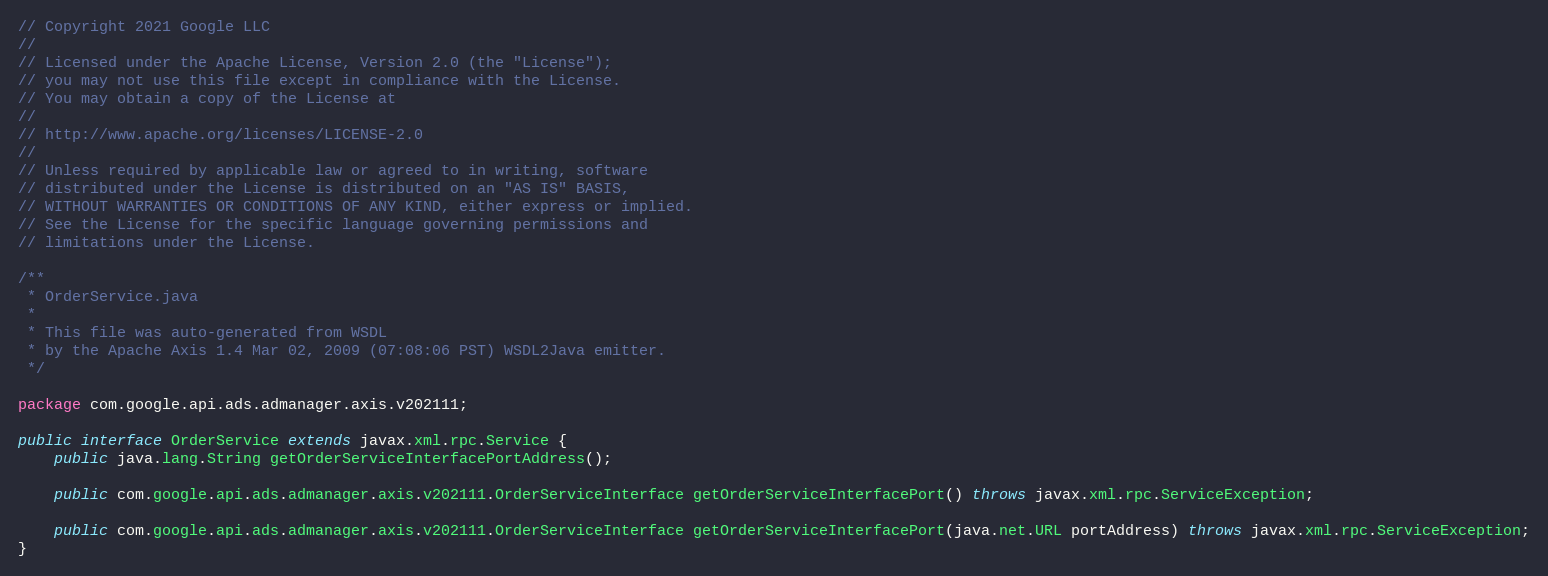<code> <loc_0><loc_0><loc_500><loc_500><_Java_>// Copyright 2021 Google LLC
//
// Licensed under the Apache License, Version 2.0 (the "License");
// you may not use this file except in compliance with the License.
// You may obtain a copy of the License at
//
// http://www.apache.org/licenses/LICENSE-2.0
//
// Unless required by applicable law or agreed to in writing, software
// distributed under the License is distributed on an "AS IS" BASIS,
// WITHOUT WARRANTIES OR CONDITIONS OF ANY KIND, either express or implied.
// See the License for the specific language governing permissions and
// limitations under the License.

/**
 * OrderService.java
 *
 * This file was auto-generated from WSDL
 * by the Apache Axis 1.4 Mar 02, 2009 (07:08:06 PST) WSDL2Java emitter.
 */

package com.google.api.ads.admanager.axis.v202111;

public interface OrderService extends javax.xml.rpc.Service {
    public java.lang.String getOrderServiceInterfacePortAddress();

    public com.google.api.ads.admanager.axis.v202111.OrderServiceInterface getOrderServiceInterfacePort() throws javax.xml.rpc.ServiceException;

    public com.google.api.ads.admanager.axis.v202111.OrderServiceInterface getOrderServiceInterfacePort(java.net.URL portAddress) throws javax.xml.rpc.ServiceException;
}
</code> 